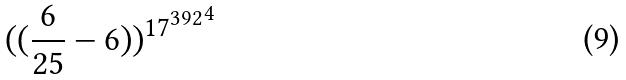<formula> <loc_0><loc_0><loc_500><loc_500>( ( \frac { 6 } { 2 5 } - 6 ) ) ^ { { 1 7 ^ { 3 9 2 } } ^ { 4 } }</formula> 